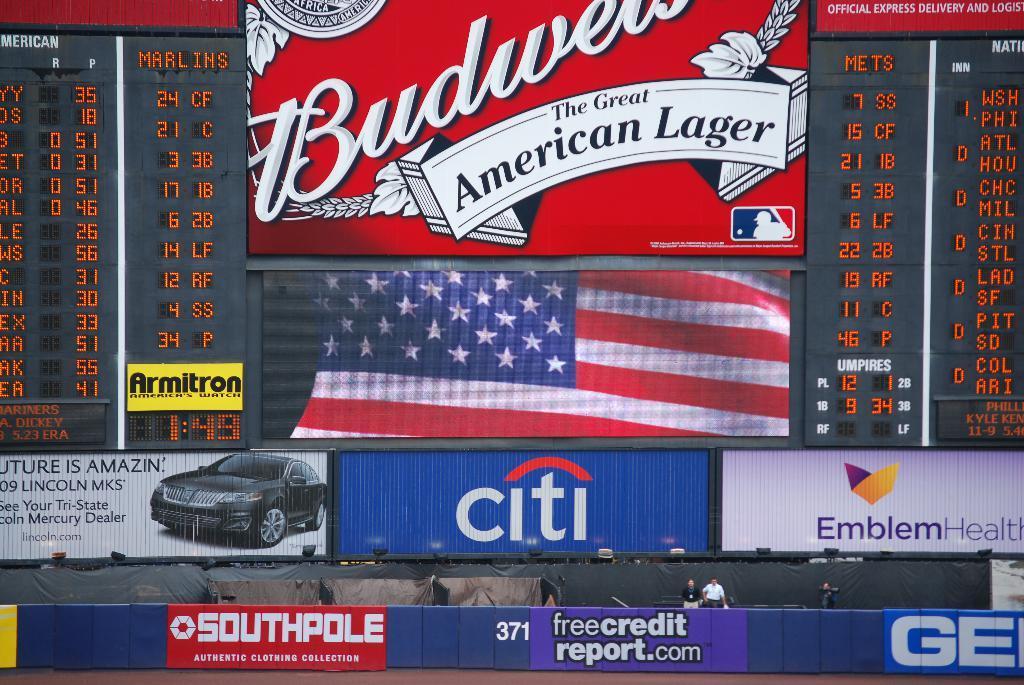How would you summarize this image in a sentence or two? The picture is clicked in the stadium. At the bottom of the picture there are banners, boards, people, curtains and lights. At the top there are board, american flag and scoreboards. 